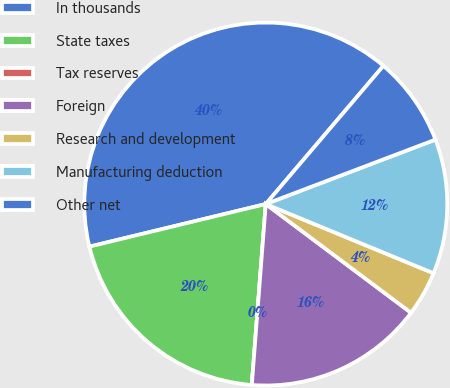Convert chart to OTSL. <chart><loc_0><loc_0><loc_500><loc_500><pie_chart><fcel>In thousands<fcel>State taxes<fcel>Tax reserves<fcel>Foreign<fcel>Research and development<fcel>Manufacturing deduction<fcel>Other net<nl><fcel>39.99%<fcel>20.0%<fcel>0.0%<fcel>16.0%<fcel>4.0%<fcel>12.0%<fcel>8.0%<nl></chart> 